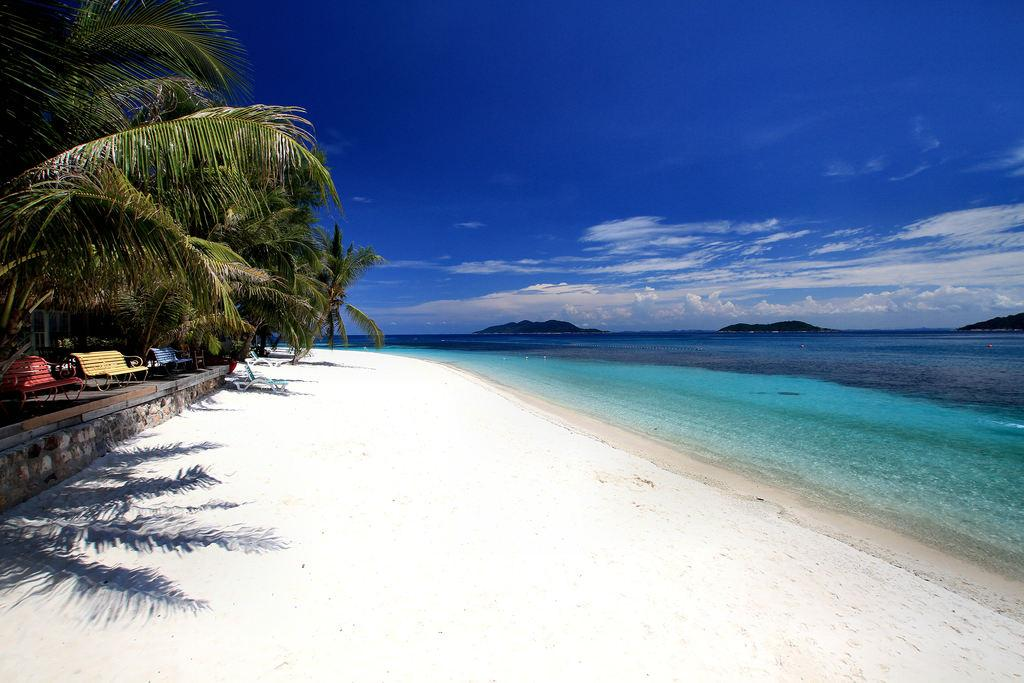What type of natural environment is shown in the image? The image depicts a seashore. What can be seen on the left side of the image? There are green trees on the left side of the image. What type of seating is available in the image? There are benches in the image. What body of water is visible in the image? There is a sea in the image. What is the color of the sky in the image? The sky is blue in the image. What type of polish is being applied to the grapes in the image? There are no grapes or polish present in the image; it depicts a seashore with green trees, benches, a sea, and a blue sky. 